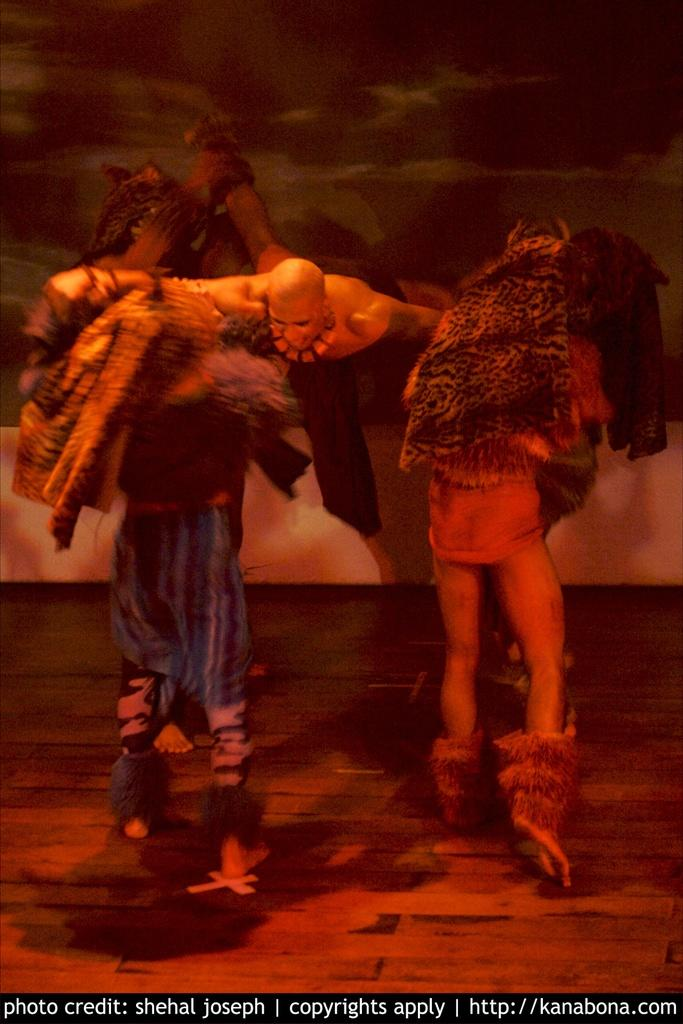How many people are in the image? There are three persons in the image. What are the people wearing? The three persons are wearing costumes. Can you describe the position of the man in the middle? The man in the middle is in the middle of the group. What is the man in the middle doing? The man in the middle is shouting. What type of flooring is visible at the bottom of the image? There is a wooden floor visible at the bottom of the image. What type of payment is required to enter the park in the image? There is no park or payment mentioned in the image; it features three people in costumes. 